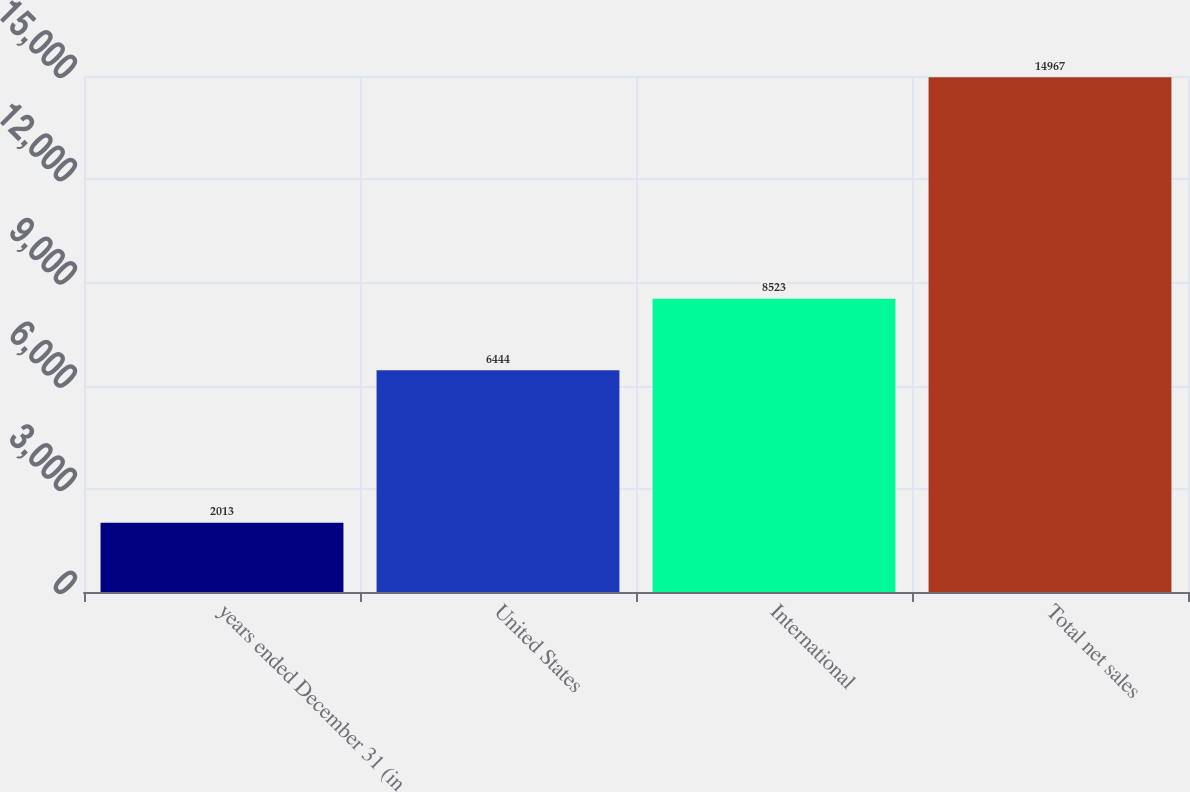Convert chart to OTSL. <chart><loc_0><loc_0><loc_500><loc_500><bar_chart><fcel>years ended December 31 (in<fcel>United States<fcel>International<fcel>Total net sales<nl><fcel>2013<fcel>6444<fcel>8523<fcel>14967<nl></chart> 